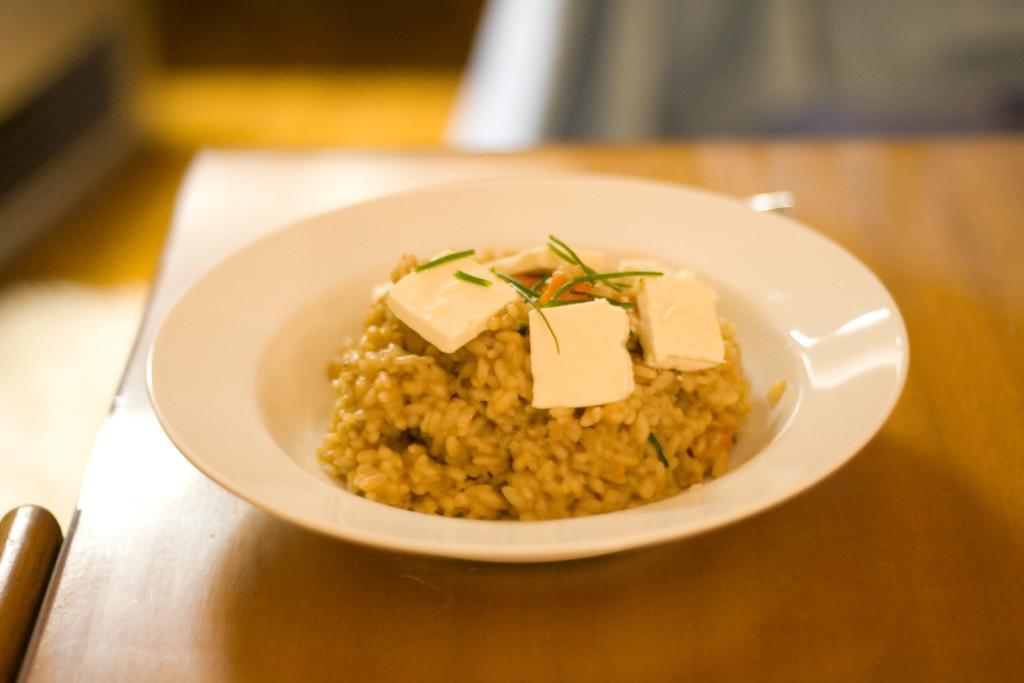Could you give a brief overview of what you see in this image? On the table there is a plate. In the plate we can see the rice, cheese and other objects. Beside the table there is a chair. At the top we can see the cloth. 